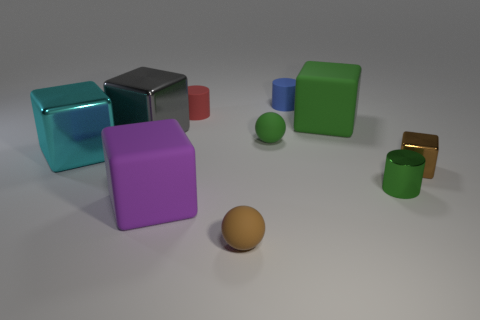Subtract all brown metal blocks. How many blocks are left? 4 Subtract all red cylinders. How many cylinders are left? 2 Subtract 2 cylinders. How many cylinders are left? 1 Subtract all cylinders. How many objects are left? 7 Subtract all tiny red matte cylinders. Subtract all gray shiny objects. How many objects are left? 8 Add 7 small matte spheres. How many small matte spheres are left? 9 Add 3 small red metal balls. How many small red metal balls exist? 3 Subtract 0 blue spheres. How many objects are left? 10 Subtract all purple cubes. Subtract all blue cylinders. How many cubes are left? 4 